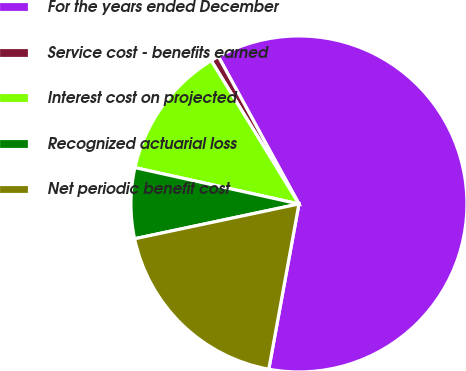Convert chart to OTSL. <chart><loc_0><loc_0><loc_500><loc_500><pie_chart><fcel>For the years ended December<fcel>Service cost - benefits earned<fcel>Interest cost on projected<fcel>Recognized actuarial loss<fcel>Net periodic benefit cost<nl><fcel>60.83%<fcel>0.78%<fcel>12.79%<fcel>6.79%<fcel>18.8%<nl></chart> 